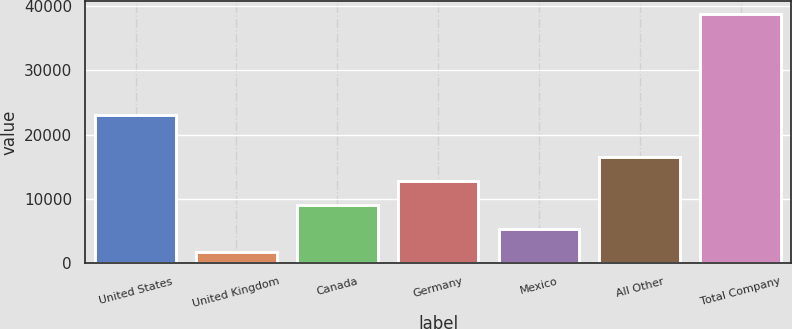Convert chart. <chart><loc_0><loc_0><loc_500><loc_500><bar_chart><fcel>United States<fcel>United Kingdom<fcel>Canada<fcel>Germany<fcel>Mexico<fcel>All Other<fcel>Total Company<nl><fcel>22986<fcel>1668<fcel>9100.4<fcel>12816.6<fcel>5384.2<fcel>16532.8<fcel>38830<nl></chart> 